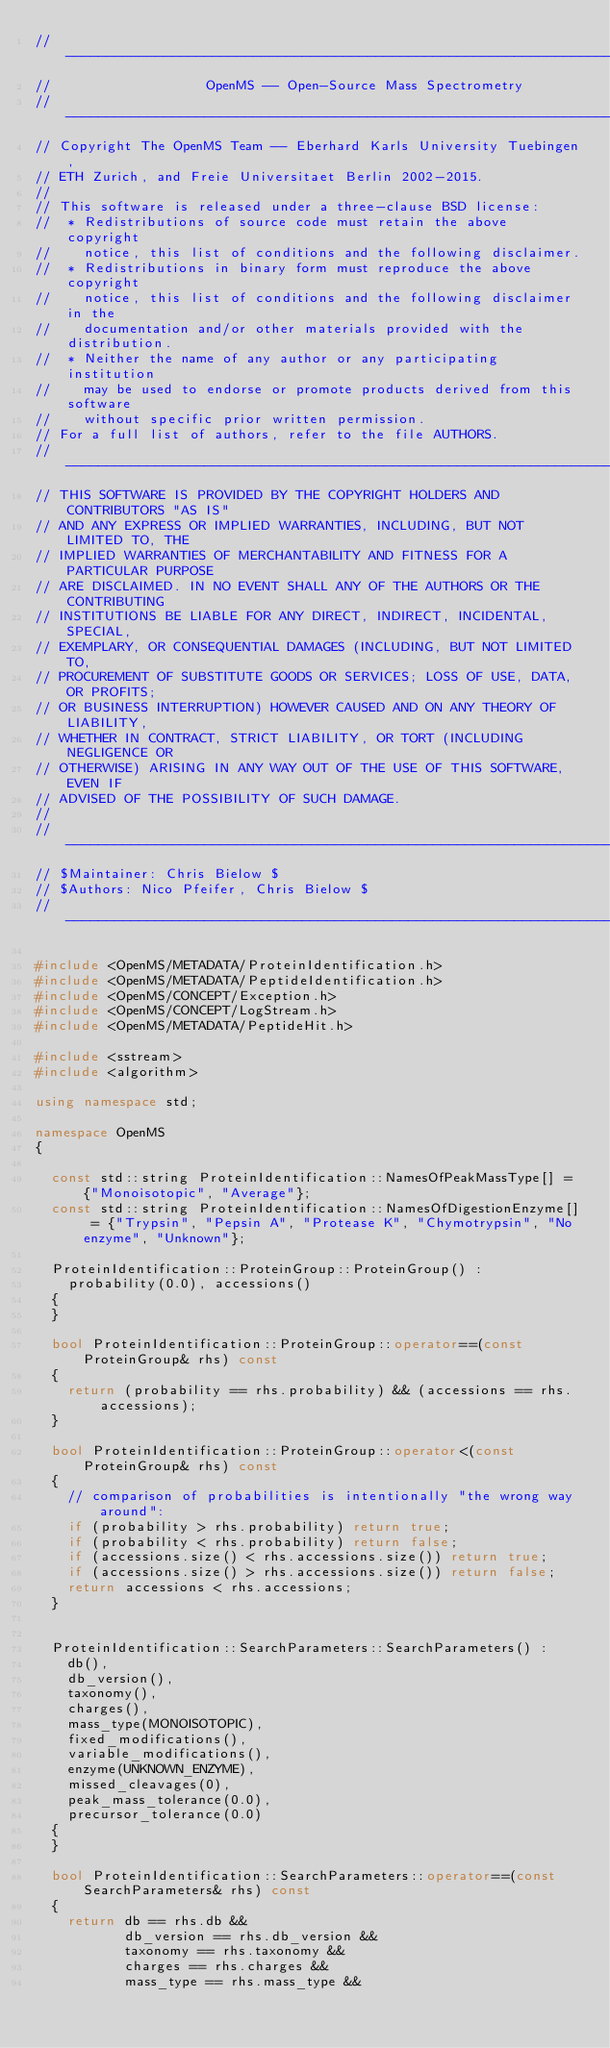Convert code to text. <code><loc_0><loc_0><loc_500><loc_500><_C++_>// --------------------------------------------------------------------------
//                   OpenMS -- Open-Source Mass Spectrometry
// --------------------------------------------------------------------------
// Copyright The OpenMS Team -- Eberhard Karls University Tuebingen,
// ETH Zurich, and Freie Universitaet Berlin 2002-2015.
//
// This software is released under a three-clause BSD license:
//  * Redistributions of source code must retain the above copyright
//    notice, this list of conditions and the following disclaimer.
//  * Redistributions in binary form must reproduce the above copyright
//    notice, this list of conditions and the following disclaimer in the
//    documentation and/or other materials provided with the distribution.
//  * Neither the name of any author or any participating institution
//    may be used to endorse or promote products derived from this software
//    without specific prior written permission.
// For a full list of authors, refer to the file AUTHORS.
// --------------------------------------------------------------------------
// THIS SOFTWARE IS PROVIDED BY THE COPYRIGHT HOLDERS AND CONTRIBUTORS "AS IS"
// AND ANY EXPRESS OR IMPLIED WARRANTIES, INCLUDING, BUT NOT LIMITED TO, THE
// IMPLIED WARRANTIES OF MERCHANTABILITY AND FITNESS FOR A PARTICULAR PURPOSE
// ARE DISCLAIMED. IN NO EVENT SHALL ANY OF THE AUTHORS OR THE CONTRIBUTING
// INSTITUTIONS BE LIABLE FOR ANY DIRECT, INDIRECT, INCIDENTAL, SPECIAL,
// EXEMPLARY, OR CONSEQUENTIAL DAMAGES (INCLUDING, BUT NOT LIMITED TO,
// PROCUREMENT OF SUBSTITUTE GOODS OR SERVICES; LOSS OF USE, DATA, OR PROFITS;
// OR BUSINESS INTERRUPTION) HOWEVER CAUSED AND ON ANY THEORY OF LIABILITY,
// WHETHER IN CONTRACT, STRICT LIABILITY, OR TORT (INCLUDING NEGLIGENCE OR
// OTHERWISE) ARISING IN ANY WAY OUT OF THE USE OF THIS SOFTWARE, EVEN IF
// ADVISED OF THE POSSIBILITY OF SUCH DAMAGE.
//
// --------------------------------------------------------------------------
// $Maintainer: Chris Bielow $
// $Authors: Nico Pfeifer, Chris Bielow $
// --------------------------------------------------------------------------

#include <OpenMS/METADATA/ProteinIdentification.h>
#include <OpenMS/METADATA/PeptideIdentification.h>
#include <OpenMS/CONCEPT/Exception.h>
#include <OpenMS/CONCEPT/LogStream.h>
#include <OpenMS/METADATA/PeptideHit.h>

#include <sstream>
#include <algorithm>

using namespace std;

namespace OpenMS
{

  const std::string ProteinIdentification::NamesOfPeakMassType[] = {"Monoisotopic", "Average"};
  const std::string ProteinIdentification::NamesOfDigestionEnzyme[] = {"Trypsin", "Pepsin A", "Protease K", "Chymotrypsin", "No enzyme", "Unknown"};

  ProteinIdentification::ProteinGroup::ProteinGroup() :
    probability(0.0), accessions()
  {
  }

  bool ProteinIdentification::ProteinGroup::operator==(const ProteinGroup& rhs) const
  {
    return (probability == rhs.probability) && (accessions == rhs.accessions);
  }

  bool ProteinIdentification::ProteinGroup::operator<(const ProteinGroup& rhs) const
  {
    // comparison of probabilities is intentionally "the wrong way around":
    if (probability > rhs.probability) return true;
    if (probability < rhs.probability) return false;
    if (accessions.size() < rhs.accessions.size()) return true;
    if (accessions.size() > rhs.accessions.size()) return false;
    return accessions < rhs.accessions;
  }


  ProteinIdentification::SearchParameters::SearchParameters() :
    db(),
    db_version(),
    taxonomy(),
    charges(),
    mass_type(MONOISOTOPIC),
    fixed_modifications(),
    variable_modifications(),
    enzyme(UNKNOWN_ENZYME),
    missed_cleavages(0),
    peak_mass_tolerance(0.0),
    precursor_tolerance(0.0)
  {
  }

  bool ProteinIdentification::SearchParameters::operator==(const SearchParameters& rhs) const
  {
    return db == rhs.db &&
           db_version == rhs.db_version &&
           taxonomy == rhs.taxonomy &&
           charges == rhs.charges &&
           mass_type == rhs.mass_type &&</code> 